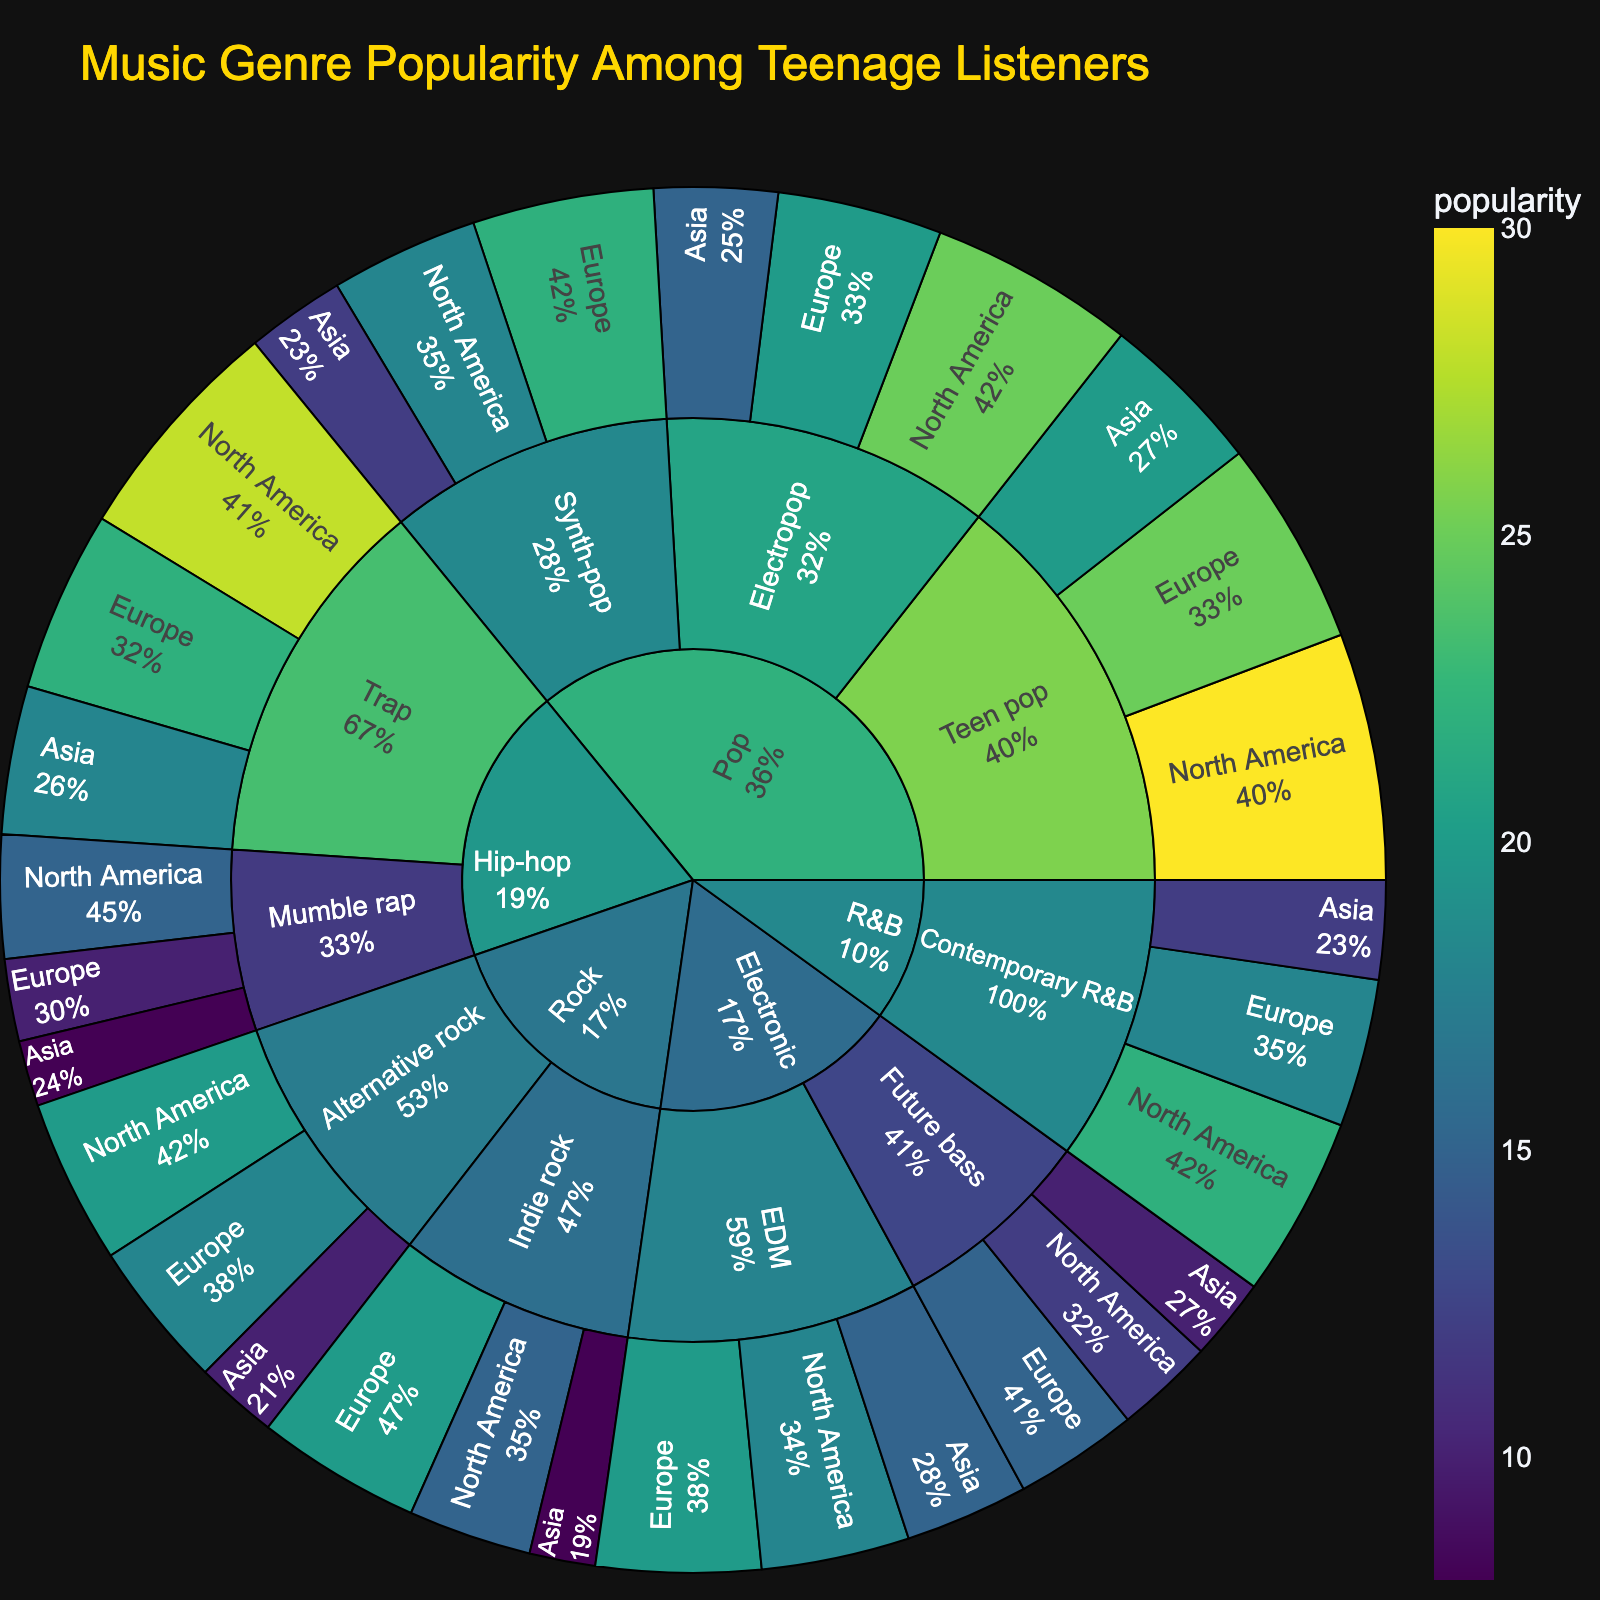How popular is the Teen pop subgenre in North America compared to Europe? To determine the popularity of Teen pop in North America and Europe, refer to the respective parent and child segments in the Sunburst Plot. Teen pop in North America is marked with a larger segment compared to Europe, showing popularity percentages of 30% vs 25%.
Answer: More popular in North America Among the Pop subgenres, which one is least popular in Asia? Look at the segments under the Pop genre for Asia. Electropop, Synth-pop, and Teen pop have popularity percentages of 15%, 12%, and 20%, respectively. Hence, Synth-pop is the least popular.
Answer: Synth-pop Which subgenre of Hip-hop is more popular in Europe, Trap, or Mumble rap? Look at the Hip-hop segments in Europe. Trap has a popularity value of 22%, while Mumble rap has 10%. Therefore, Trap is more popular.
Answer: Trap If you sum the popularity of Electropop across all regions, what's the total? Calculate the sum of popularity values of Electropop in North America, Europe, and Asia which are 25, 20, and 15 respectively. 25 + 20 + 15 = 60
Answer: 60 Which music genre holds the highest overall popularity among teenage listeners? Compare the cumulative size of all segments under each main genre. Pop has the highest number of large segments, indicating it holds the highest overall popularity.
Answer: Pop What is the total popularity of Alternative rock across all regions compared to Indie rock? Sum the popularity values of Alternative rock and Indie rock segments across North America, Europe, and Asia. Alternative rock: 20 + 18 + 10 = 48; Indie rock: 15 + 20 + 8 = 43. Alternative rock has a higher total popularity.
Answer: Alternative rock Which region has the highest popularity for Contemporary R&B? Look specifically at the Contemporary R&B segments for each region. North America shows the highest percentage at 22%.
Answer: North America Is Future bass more popular in North America or Asia? Check the popularity segments for Future bass in North America and Asia. North America has a value of 12%, while Asia has 10%. Hence, it's more popular in North America.
Answer: North America Compare the popularity of Electropop and Teen pop in Europe. Which one is more popular? Look at the segments of Electropop and Teen pop in Europe. Electropop has a popularity percentage of 20%, while Teen pop has 25%. Teen pop is more popular.
Answer: Teen pop Which genre in North America shows the highest popularity? Examine the segments under each genre specifically for North America. The highest value (30%) is under the Teen pop subgenre in the Pop genre.
Answer: Pop 